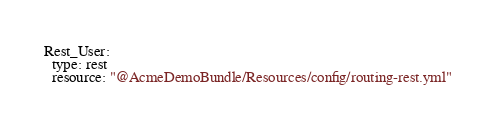Convert code to text. <code><loc_0><loc_0><loc_500><loc_500><_YAML_>Rest_User:
  type: rest
  resource: "@AcmeDemoBundle/Resources/config/routing-rest.yml"</code> 